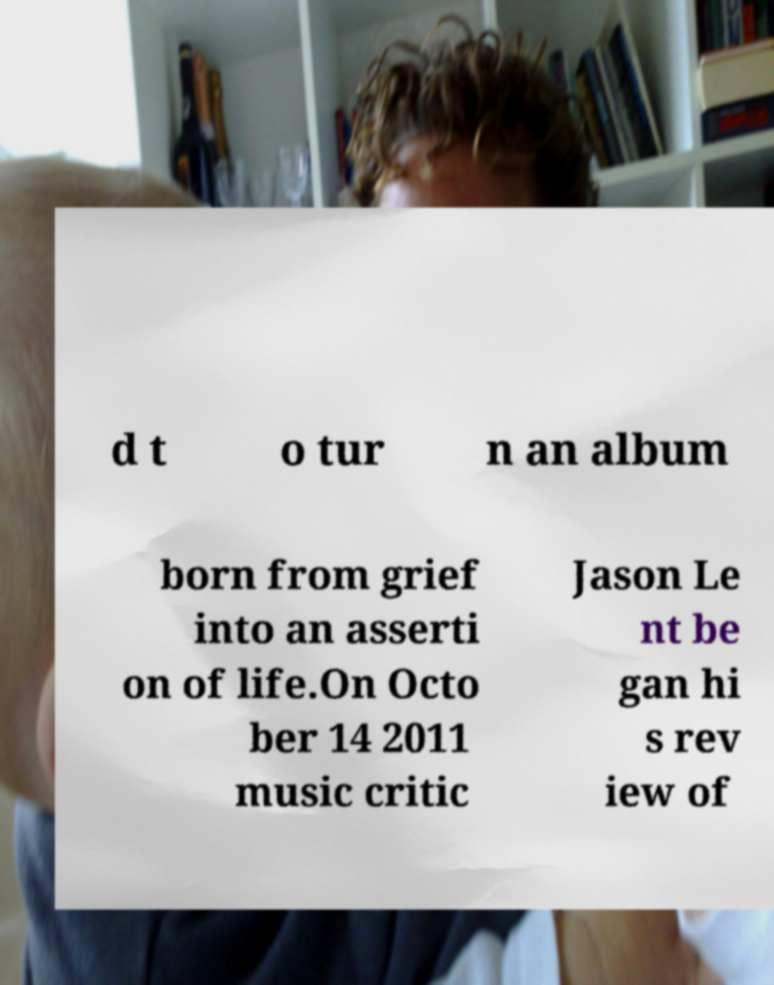For documentation purposes, I need the text within this image transcribed. Could you provide that? d t o tur n an album born from grief into an asserti on of life.On Octo ber 14 2011 music critic Jason Le nt be gan hi s rev iew of 